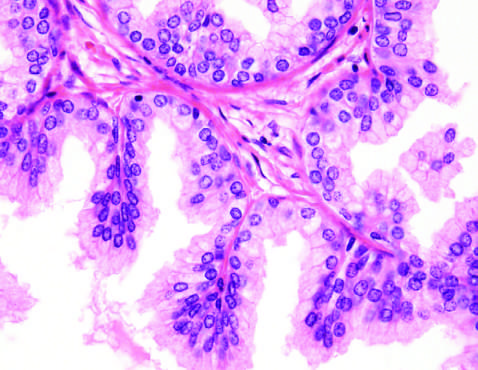does low-power photomicrograph demonstrate a well-demarcated nodule at the right of the field, with a portion of urethra seen to the left?
Answer the question using a single word or phrase. Yes 